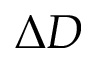<formula> <loc_0><loc_0><loc_500><loc_500>\Delta D</formula> 